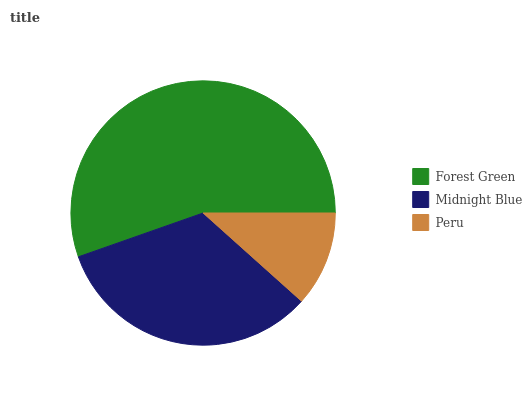Is Peru the minimum?
Answer yes or no. Yes. Is Forest Green the maximum?
Answer yes or no. Yes. Is Midnight Blue the minimum?
Answer yes or no. No. Is Midnight Blue the maximum?
Answer yes or no. No. Is Forest Green greater than Midnight Blue?
Answer yes or no. Yes. Is Midnight Blue less than Forest Green?
Answer yes or no. Yes. Is Midnight Blue greater than Forest Green?
Answer yes or no. No. Is Forest Green less than Midnight Blue?
Answer yes or no. No. Is Midnight Blue the high median?
Answer yes or no. Yes. Is Midnight Blue the low median?
Answer yes or no. Yes. Is Peru the high median?
Answer yes or no. No. Is Forest Green the low median?
Answer yes or no. No. 